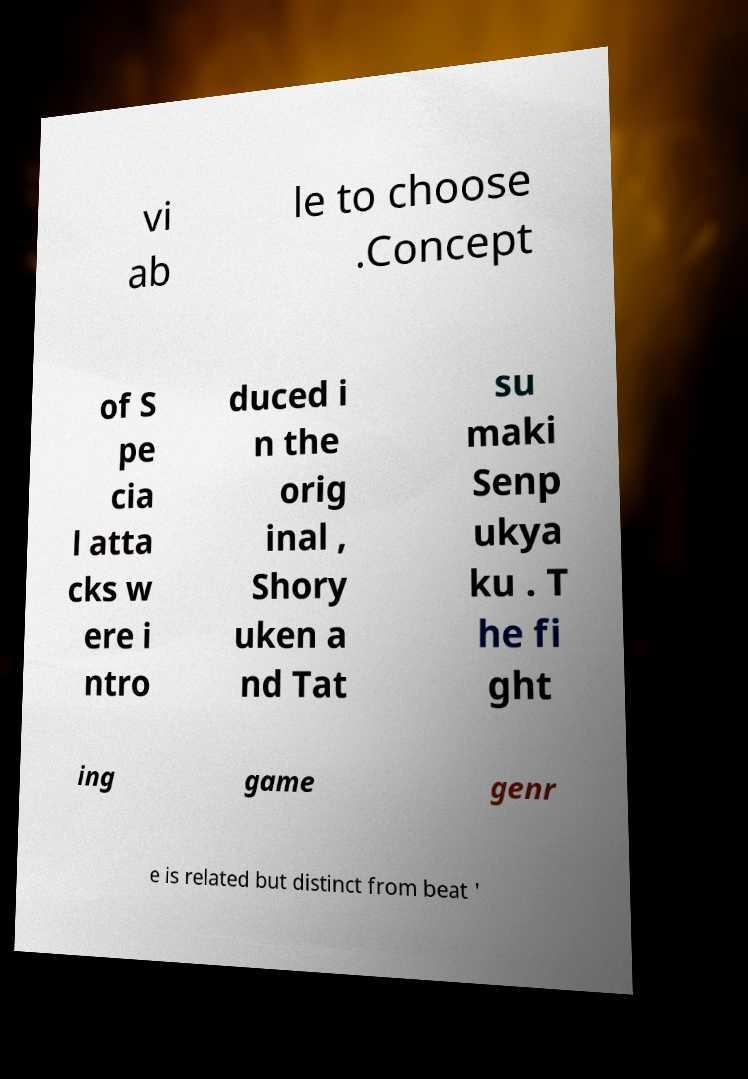I need the written content from this picture converted into text. Can you do that? vi ab le to choose .Concept of S pe cia l atta cks w ere i ntro duced i n the orig inal , Shory uken a nd Tat su maki Senp ukya ku . T he fi ght ing game genr e is related but distinct from beat ' 